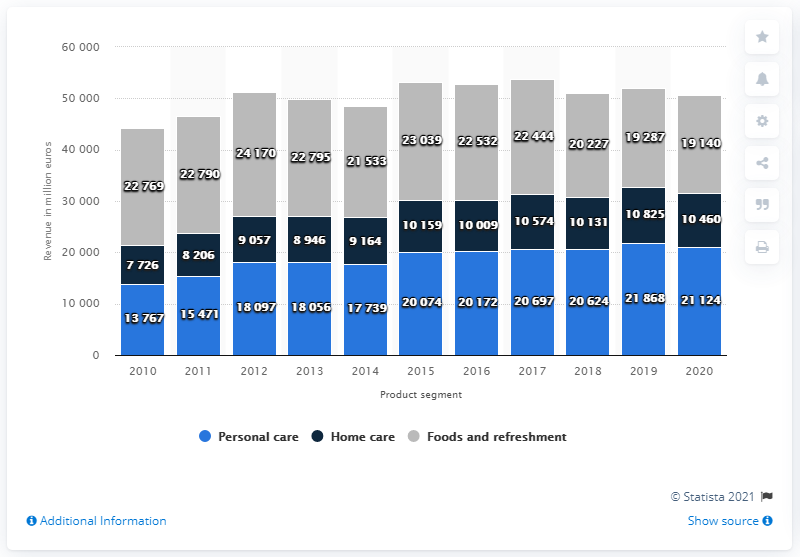Draw attention to some important aspects in this diagram. Unilever's personal care product segment generated global revenue of 21,124 in 2020. 